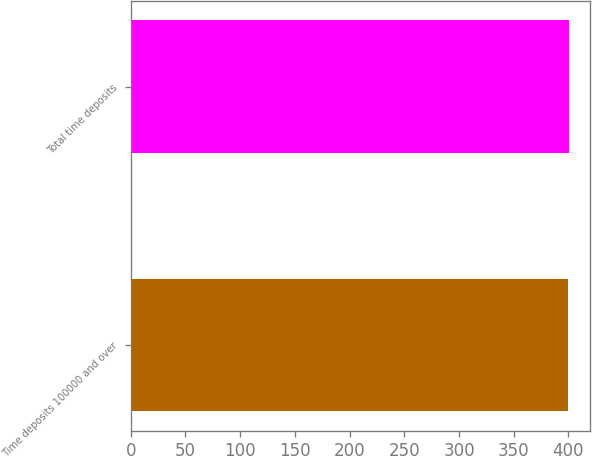Convert chart to OTSL. <chart><loc_0><loc_0><loc_500><loc_500><bar_chart><fcel>Time deposits 100000 and over<fcel>Total time deposits<nl><fcel>400<fcel>400.1<nl></chart> 